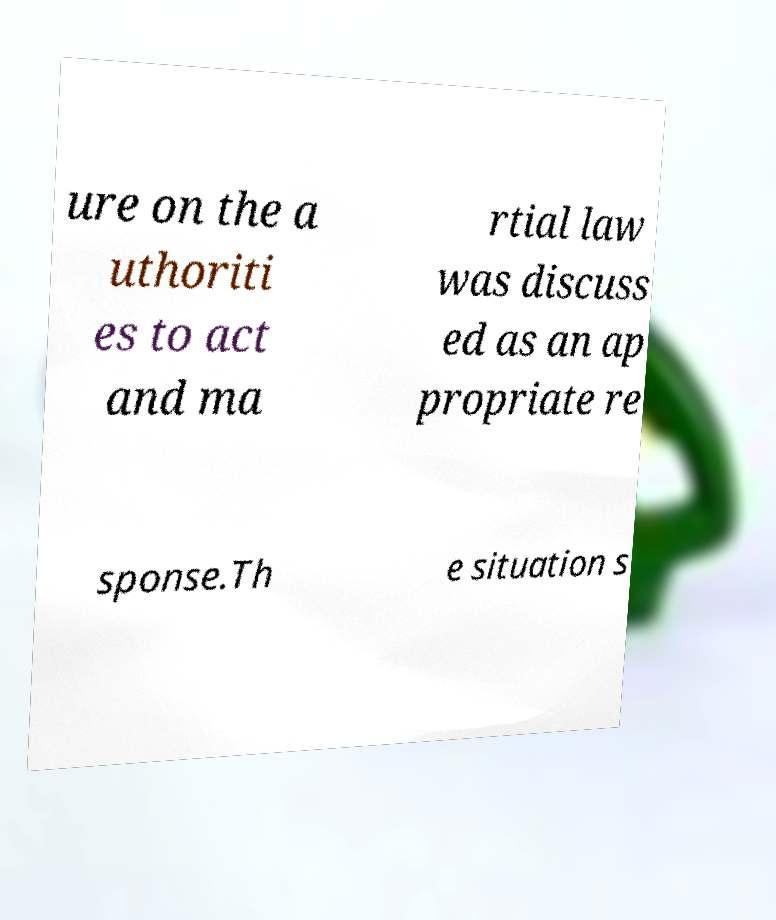Can you accurately transcribe the text from the provided image for me? ure on the a uthoriti es to act and ma rtial law was discuss ed as an ap propriate re sponse.Th e situation s 